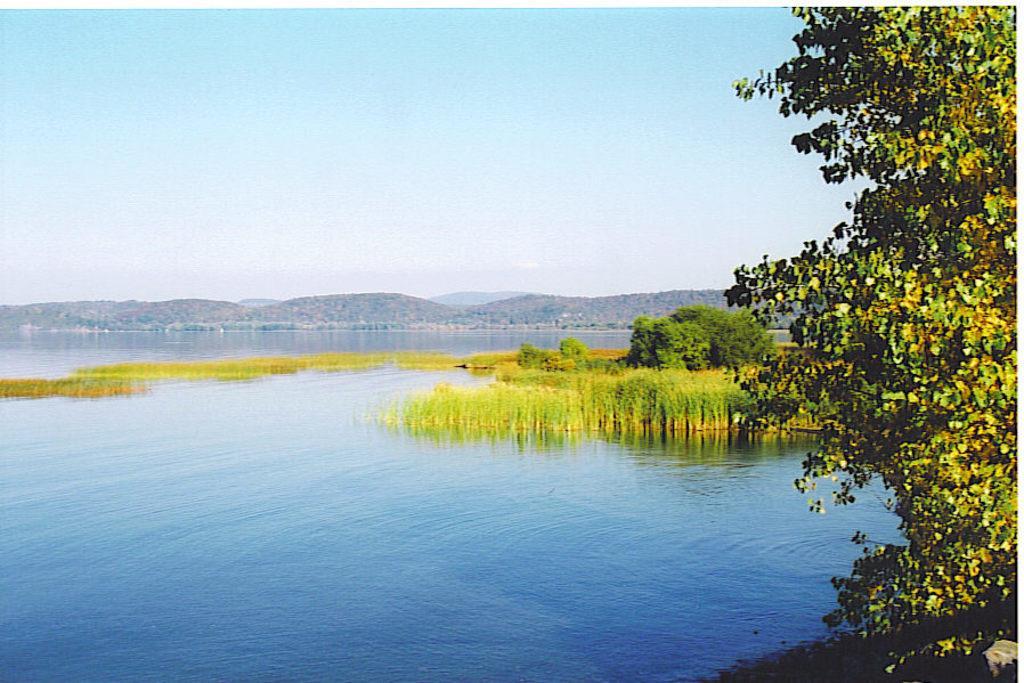Please provide a concise description of this image. In this picture, we can water, plants, trees, mountains, and the sky. 